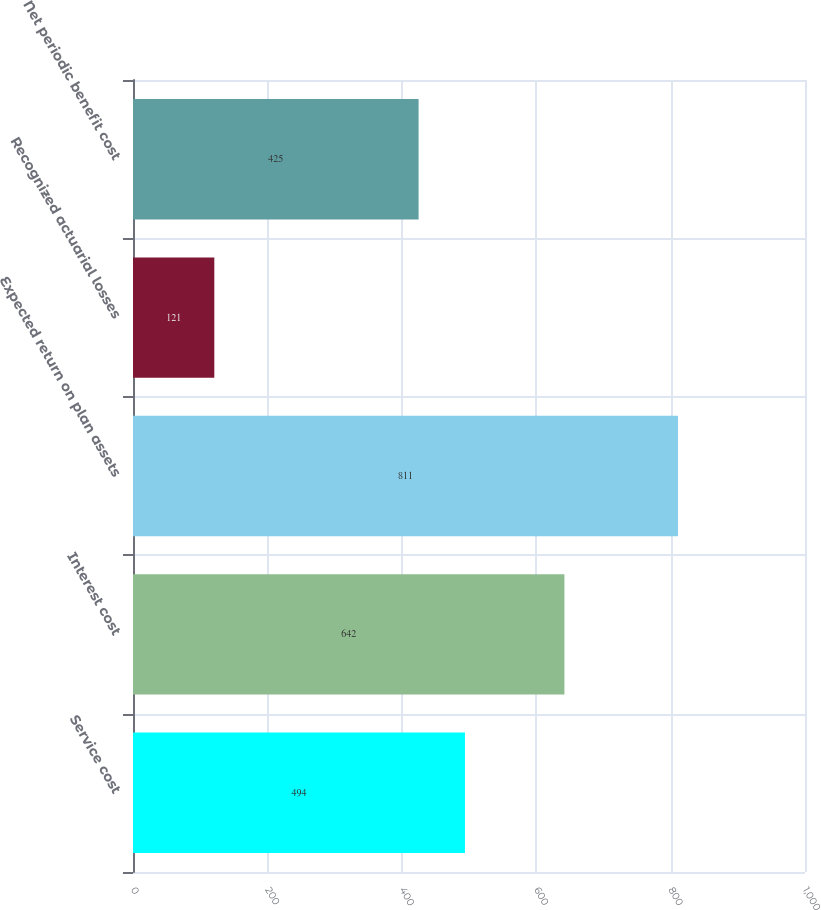Convert chart to OTSL. <chart><loc_0><loc_0><loc_500><loc_500><bar_chart><fcel>Service cost<fcel>Interest cost<fcel>Expected return on plan assets<fcel>Recognized actuarial losses<fcel>Net periodic benefit cost<nl><fcel>494<fcel>642<fcel>811<fcel>121<fcel>425<nl></chart> 